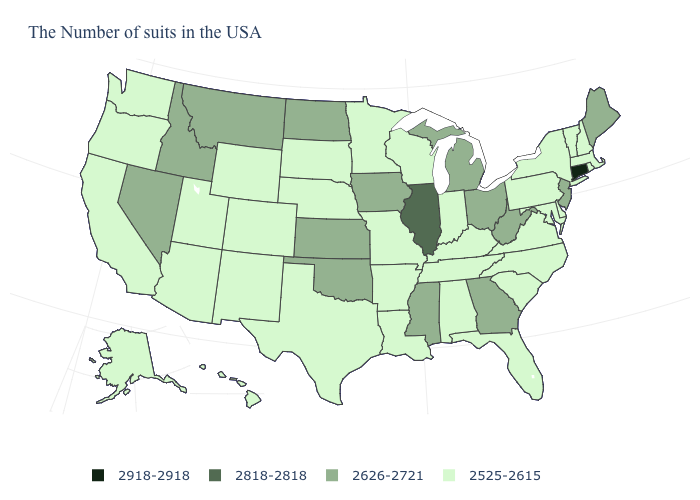Among the states that border Illinois , which have the lowest value?
Answer briefly. Kentucky, Indiana, Wisconsin, Missouri. Does West Virginia have a lower value than Illinois?
Write a very short answer. Yes. What is the value of Illinois?
Be succinct. 2818-2818. Name the states that have a value in the range 2918-2918?
Quick response, please. Connecticut. Name the states that have a value in the range 2525-2615?
Be succinct. Massachusetts, Rhode Island, New Hampshire, Vermont, New York, Delaware, Maryland, Pennsylvania, Virginia, North Carolina, South Carolina, Florida, Kentucky, Indiana, Alabama, Tennessee, Wisconsin, Louisiana, Missouri, Arkansas, Minnesota, Nebraska, Texas, South Dakota, Wyoming, Colorado, New Mexico, Utah, Arizona, California, Washington, Oregon, Alaska, Hawaii. Which states have the lowest value in the USA?
Keep it brief. Massachusetts, Rhode Island, New Hampshire, Vermont, New York, Delaware, Maryland, Pennsylvania, Virginia, North Carolina, South Carolina, Florida, Kentucky, Indiana, Alabama, Tennessee, Wisconsin, Louisiana, Missouri, Arkansas, Minnesota, Nebraska, Texas, South Dakota, Wyoming, Colorado, New Mexico, Utah, Arizona, California, Washington, Oregon, Alaska, Hawaii. Name the states that have a value in the range 2525-2615?
Short answer required. Massachusetts, Rhode Island, New Hampshire, Vermont, New York, Delaware, Maryland, Pennsylvania, Virginia, North Carolina, South Carolina, Florida, Kentucky, Indiana, Alabama, Tennessee, Wisconsin, Louisiana, Missouri, Arkansas, Minnesota, Nebraska, Texas, South Dakota, Wyoming, Colorado, New Mexico, Utah, Arizona, California, Washington, Oregon, Alaska, Hawaii. What is the value of Louisiana?
Short answer required. 2525-2615. What is the value of Alabama?
Write a very short answer. 2525-2615. Name the states that have a value in the range 2525-2615?
Keep it brief. Massachusetts, Rhode Island, New Hampshire, Vermont, New York, Delaware, Maryland, Pennsylvania, Virginia, North Carolina, South Carolina, Florida, Kentucky, Indiana, Alabama, Tennessee, Wisconsin, Louisiana, Missouri, Arkansas, Minnesota, Nebraska, Texas, South Dakota, Wyoming, Colorado, New Mexico, Utah, Arizona, California, Washington, Oregon, Alaska, Hawaii. Is the legend a continuous bar?
Short answer required. No. Name the states that have a value in the range 2626-2721?
Give a very brief answer. Maine, New Jersey, West Virginia, Ohio, Georgia, Michigan, Mississippi, Iowa, Kansas, Oklahoma, North Dakota, Montana, Idaho, Nevada. Name the states that have a value in the range 2626-2721?
Concise answer only. Maine, New Jersey, West Virginia, Ohio, Georgia, Michigan, Mississippi, Iowa, Kansas, Oklahoma, North Dakota, Montana, Idaho, Nevada. Name the states that have a value in the range 2818-2818?
Give a very brief answer. Illinois. 